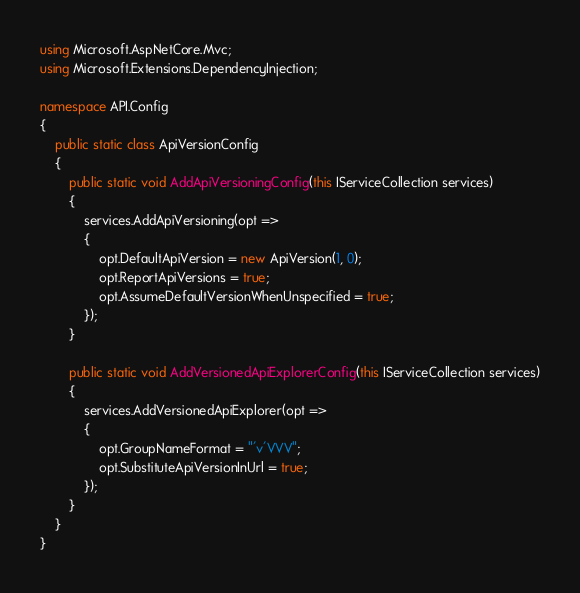<code> <loc_0><loc_0><loc_500><loc_500><_C#_>using Microsoft.AspNetCore.Mvc;
using Microsoft.Extensions.DependencyInjection;

namespace API.Config
{
    public static class ApiVersionConfig
    {
        public static void AddApiVersioningConfig(this IServiceCollection services)
        {
            services.AddApiVersioning(opt =>
            {
                opt.DefaultApiVersion = new ApiVersion(1, 0);
                opt.ReportApiVersions = true;
                opt.AssumeDefaultVersionWhenUnspecified = true;
            });
        }

        public static void AddVersionedApiExplorerConfig(this IServiceCollection services)
        {
            services.AddVersionedApiExplorer(opt =>
            {
                opt.GroupNameFormat = "'v'VVV";
                opt.SubstituteApiVersionInUrl = true;
            });
        }
    }
}</code> 